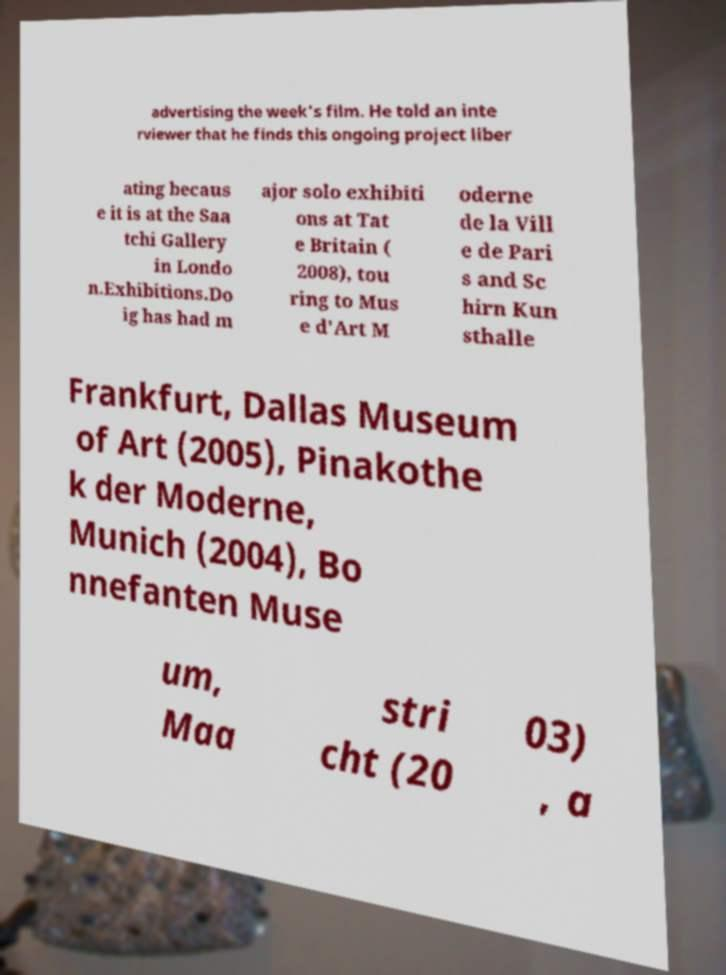Please identify and transcribe the text found in this image. advertising the week's film. He told an inte rviewer that he finds this ongoing project liber ating becaus e it is at the Saa tchi Gallery in Londo n.Exhibitions.Do ig has had m ajor solo exhibiti ons at Tat e Britain ( 2008), tou ring to Mus e d'Art M oderne de la Vill e de Pari s and Sc hirn Kun sthalle Frankfurt, Dallas Museum of Art (2005), Pinakothe k der Moderne, Munich (2004), Bo nnefanten Muse um, Maa stri cht (20 03) , a 